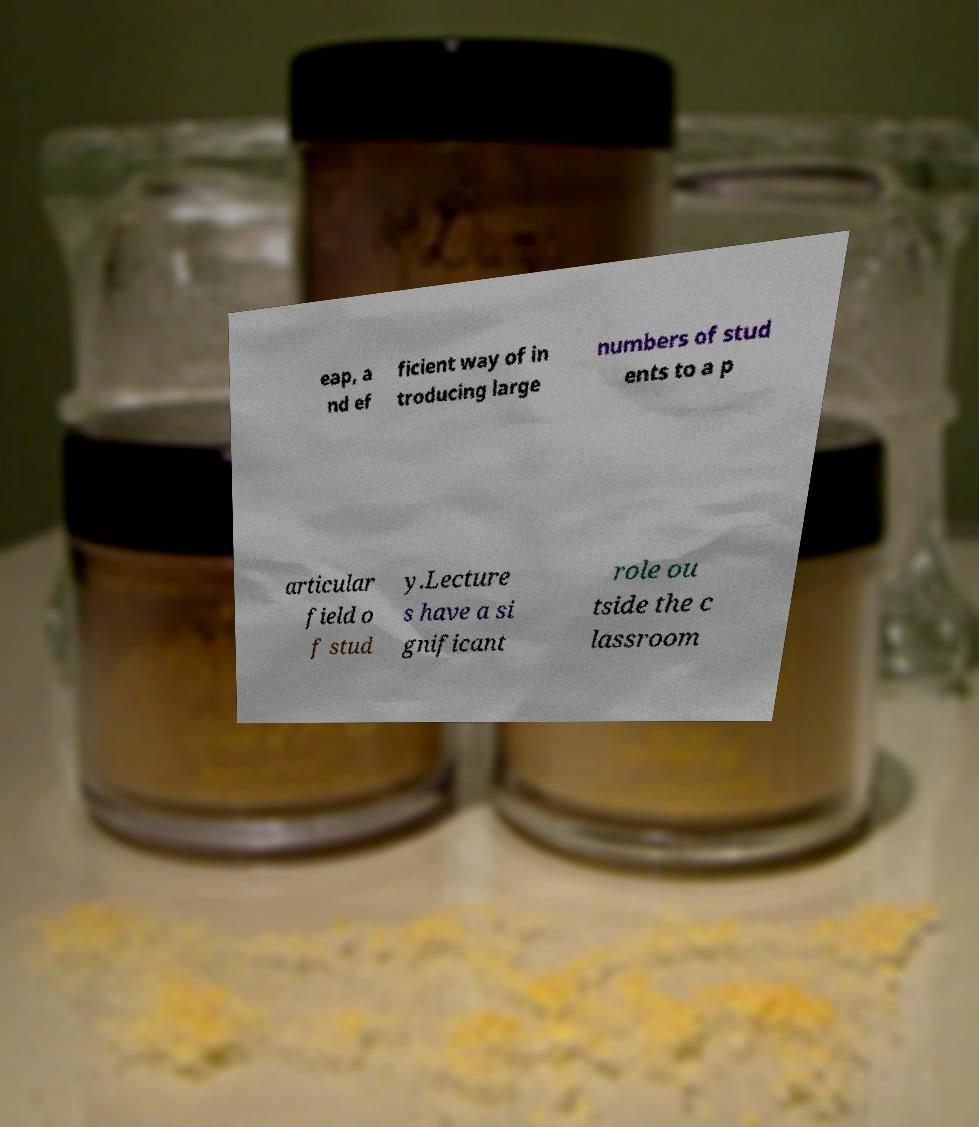For documentation purposes, I need the text within this image transcribed. Could you provide that? eap, a nd ef ficient way of in troducing large numbers of stud ents to a p articular field o f stud y.Lecture s have a si gnificant role ou tside the c lassroom 